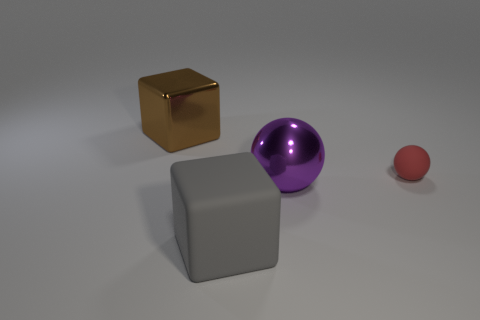What is the shape of the gray rubber object that is the same size as the shiny cube?
Make the answer very short. Cube. Are there any other large brown shiny things of the same shape as the large brown thing?
Your answer should be compact. No. What shape is the shiny object that is in front of the rubber sphere that is behind the gray rubber cube?
Offer a very short reply. Sphere. The purple object has what shape?
Make the answer very short. Sphere. The thing that is left of the cube in front of the cube behind the small matte ball is made of what material?
Ensure brevity in your answer.  Metal. What number of other objects are there of the same material as the big brown thing?
Keep it short and to the point. 1. There is a matte thing to the left of the big purple object; what number of brown metal blocks are left of it?
Provide a short and direct response. 1. How many blocks are either gray objects or brown objects?
Your response must be concise. 2. What color is the large thing that is both left of the purple metallic ball and in front of the brown shiny block?
Your response must be concise. Gray. Is there anything else that has the same color as the large ball?
Make the answer very short. No. 